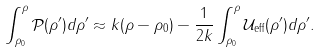<formula> <loc_0><loc_0><loc_500><loc_500>\int _ { \rho _ { 0 } } ^ { \rho } \mathcal { P } ( \rho ^ { \prime } ) d \rho ^ { \prime } \approx k ( \rho - \rho _ { 0 } ) - \frac { 1 } { 2 k } \int _ { \rho _ { 0 } } ^ { \rho } \mathcal { U } _ { \text {eff} } ( \rho ^ { \prime } ) d \rho ^ { \prime } .</formula> 